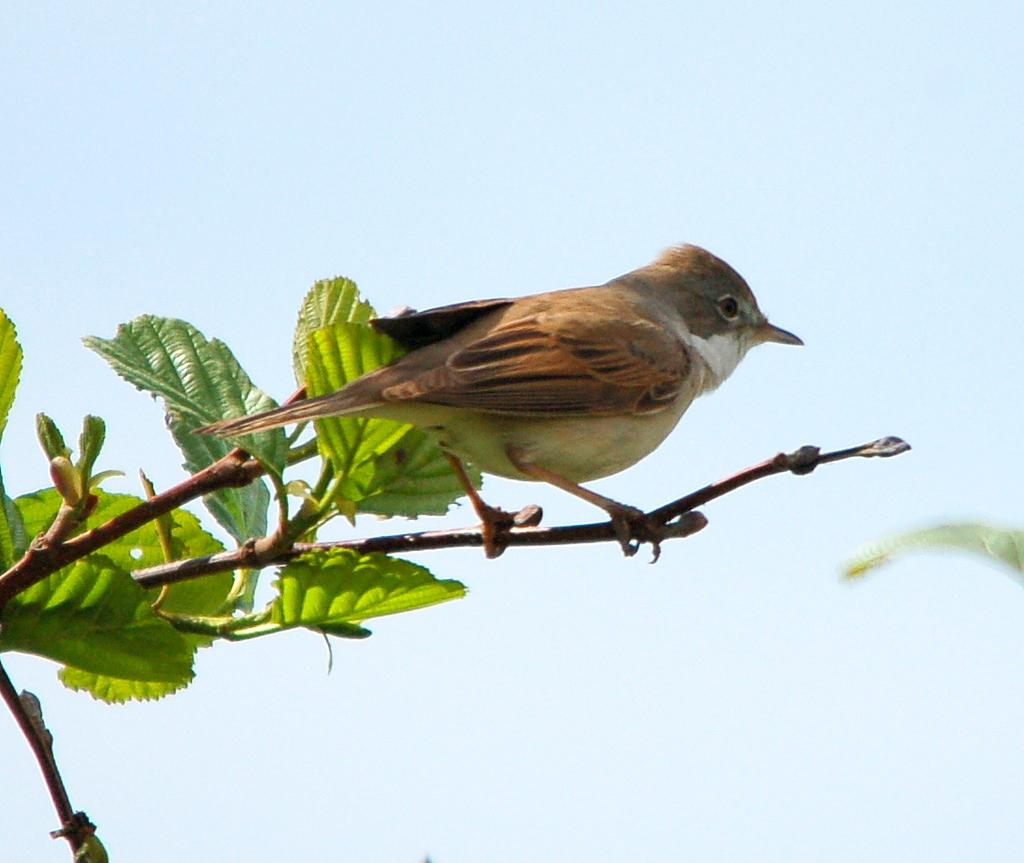What is the main subject in the center of the image? There is a bird in the center of the image. What is the bird resting on? The bird is on a stem. What type of vegetation can be seen on the left side of the image? There are leaves on the left side of the image. What can be seen in the background of the image? The sky is visible in the background of the image. What type of soap is the bird using to clean itself in the image? There is no soap present in the image, and the bird is not shown cleaning itself. 